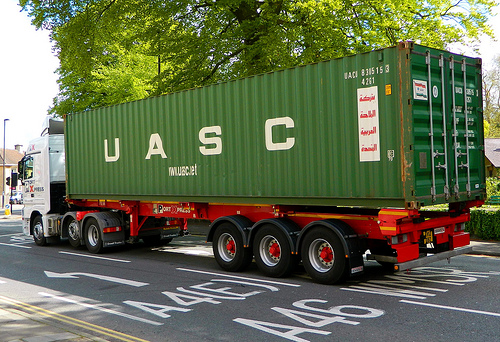Are there either any vehicles or taxis? Yes, there are vehicles and taxis in the scene. 